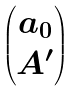<formula> <loc_0><loc_0><loc_500><loc_500>\begin{pmatrix} a _ { 0 } \\ A ^ { \prime } \end{pmatrix}</formula> 